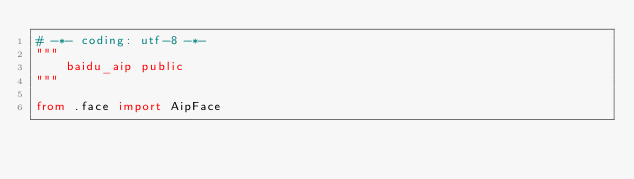<code> <loc_0><loc_0><loc_500><loc_500><_Python_># -*- coding: utf-8 -*-
"""
    baidu_aip public
"""

from .face import AipFace</code> 